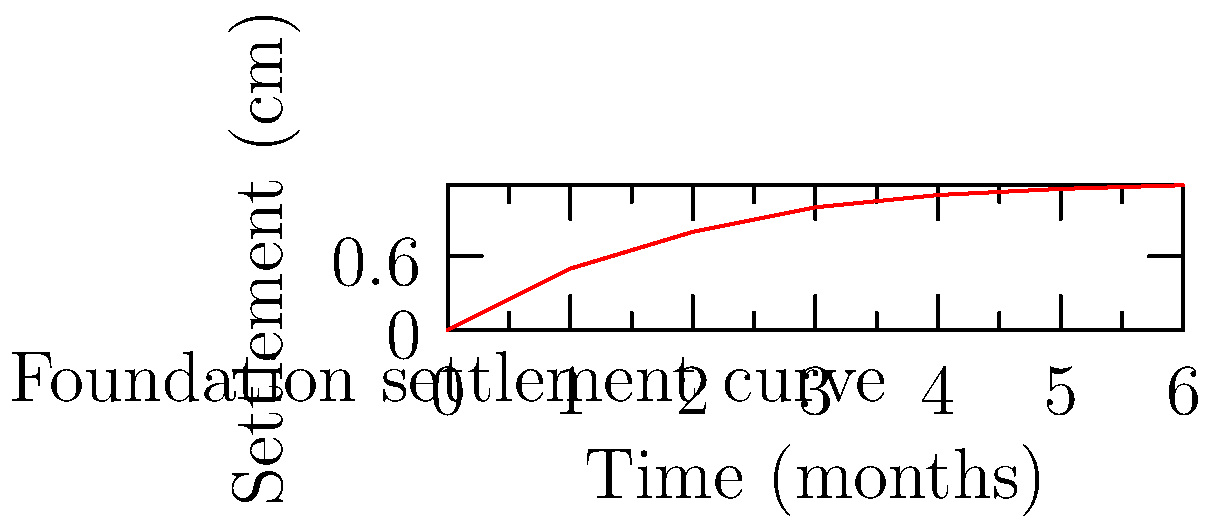As a sports psychologist working with goalkeepers, you're studying the effects of physical changes on mental performance. You come across a civil engineering graph showing the settlement of a foundation over time under a distributed load. If the rate of settlement decreases over time, how might this parallel a goalkeeper's adaptation to new training regimes? What's the approximate settlement (in cm) after 3 months according to the graph? To answer this question, we need to analyze the graph and draw parallels to sports psychology:

1. Observe the curve: The settlement increases rapidly at first, then slows down over time.

2. Interpret the curve:
   a) Initial rapid increase: This represents the foundation's immediate response to the load.
   b) Decreasing rate of change: The foundation is stabilizing and adapting to the load.

3. Parallel to goalkeeper training:
   a) Initial rapid improvement: When a goalkeeper starts a new training regime, they might see quick gains in performance.
   b) Plateauing: Over time, improvements become more gradual as the goalkeeper adapts to the new routine.

4. Psychological implications:
   a) Initial excitement and motivation during rapid improvement.
   b) Potential frustration or need for mental resilience as gains slow down.
   c) Importance of setting realistic expectations and focusing on long-term progress.

5. Reading the graph for settlement at 3 months:
   Locate the 3-month mark on the x-axis.
   Follow the vertical line up to the curve.
   Read the corresponding y-value.

The settlement at 3 months is approximately 1.0 cm.

This analysis demonstrates how principles from other fields can provide insights into sports psychology and athlete development.
Answer: 1.0 cm 